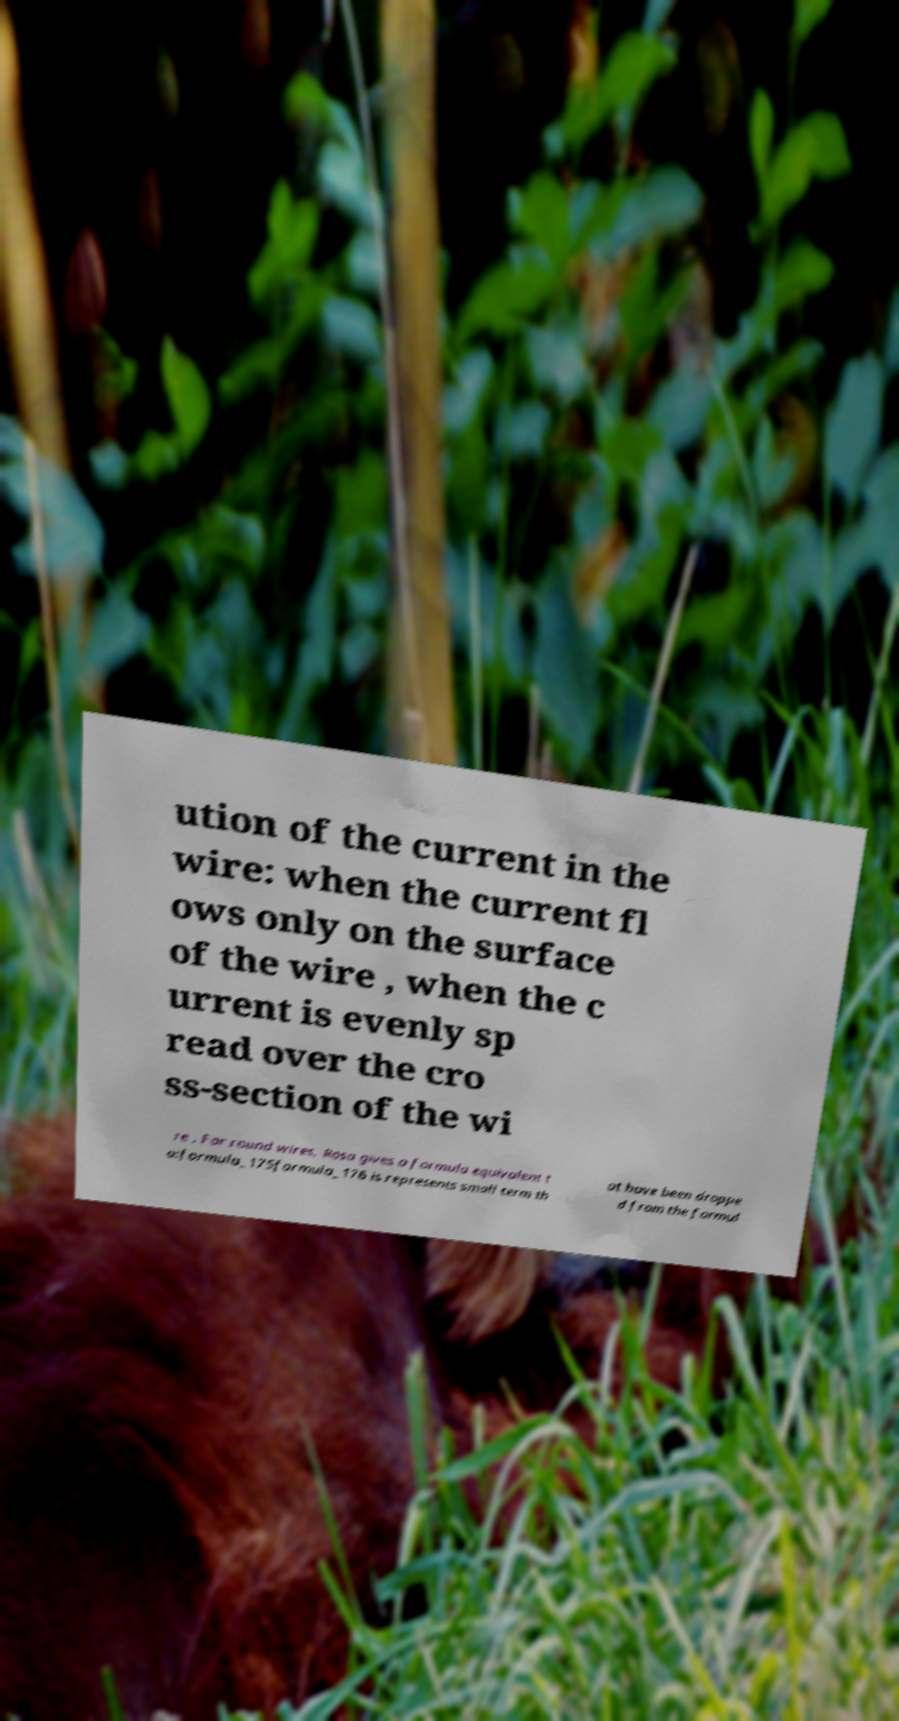Please identify and transcribe the text found in this image. ution of the current in the wire: when the current fl ows only on the surface of the wire , when the c urrent is evenly sp read over the cro ss-section of the wi re . For round wires, Rosa gives a formula equivalent t o:formula_175formula_176 is represents small term th at have been droppe d from the formul 